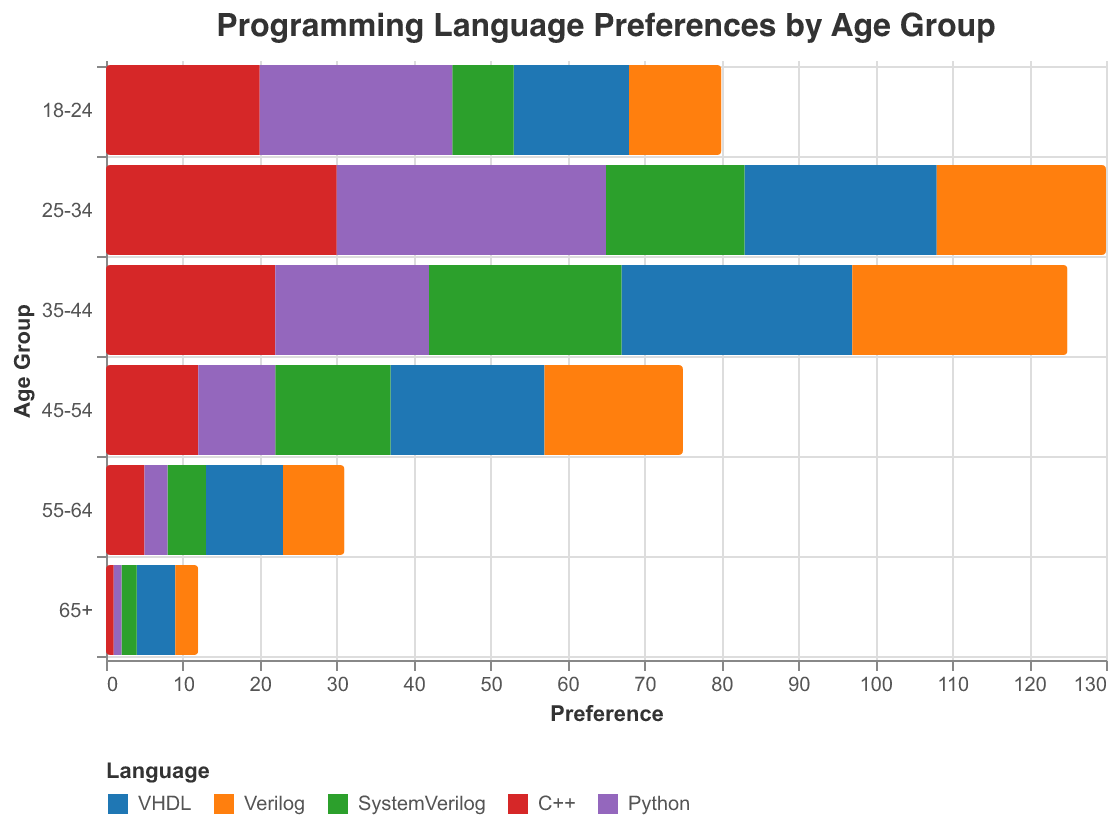What is the title of the figure? The title of the figure is clearly shown at the top. It reads, "Programming Language Preferences by Age Group."
Answer: Programming Language Preferences by Age Group Which age group has the highest preference for Python? The preference for Python is represented by positive bars with a color corresponding to Python. The age group with the longest Python bar is 25-34 (35).
Answer: 25-34 Which programming language shows a negative preference in all age groups? The negative preferences are marked on the left side of the x-axis. Only VHDL values are consistently negative across all age groups.
Answer: VHDL How does the preference for C++ change across age groups? By observing the bars corresponding to C++, we see how the height of these bars changes across age groups. The preference peaks at 25-34 (30) and gradually decreases in older groups.
Answer: Decreases with age What is the difference in preference for Verilog between the 18-24 and 45-54 age groups? Locate the Verilog bars for 18-24 (12) and 45-54 (18). Subtract the smaller from the larger value: 18 - 12.
Answer: 6 What age group has the lowest preference for SystemVerilog? Compare the bars corresponding to SystemVerilog across all age groups. The lowest value is in the 65+ group (2).
Answer: 65+ What is the sum of preferences for Python in the two youngest age groups (18-24 and 25-34)? Add the values for Python in age groups 18-24 (25) and 25-34 (35): 25 + 35.
Answer: 60 Which age group has the most balanced preference across all five languages? A balanced preference suggests shorter and more evenly distributed bars for each language. The 65+ group has relatively small and even preferences for all languages.
Answer: 65+ Compare the preference for VHDL and Python in the 35-44 age group. Identify the bars for VHDL (-30) and Python (20) in the 35-44 group. Compare their magnitudes considering VHDL's negative preference.
Answer: VHDL has a larger negative preference How does the preference for Verilog compare to SystemVerilog in the 25-34 age group? Locate the values for Verilog (22) and SystemVerilog (18) in the 25-34 group and compare them. Verilog has a higher preference.
Answer: Verilog is higher 